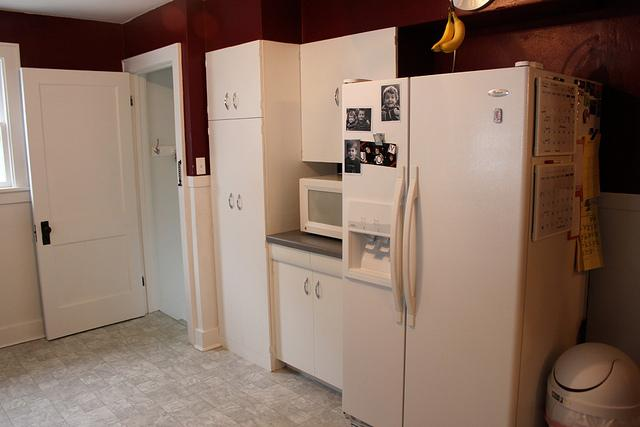What is on the side of the refrigerator? calendar 